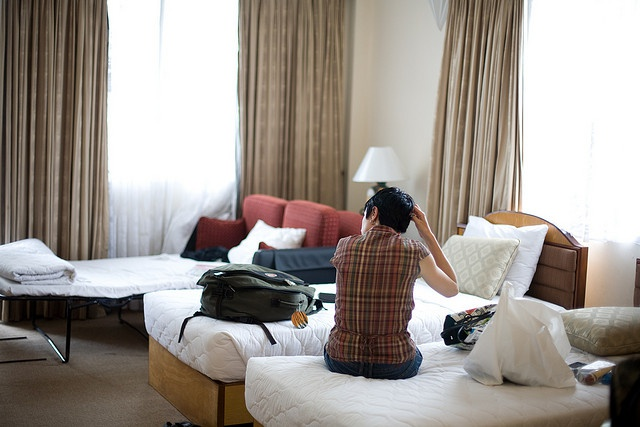Describe the objects in this image and their specific colors. I can see bed in gray, darkgray, and lightgray tones, bed in gray, lightgray, darkgray, and maroon tones, bed in gray, lavender, brown, maroon, and black tones, people in gray, black, and maroon tones, and backpack in gray, black, darkgray, and purple tones in this image. 